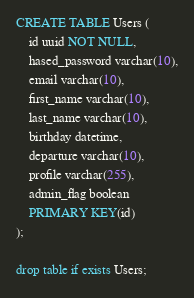Convert code to text. <code><loc_0><loc_0><loc_500><loc_500><_SQL_>CREATE TABLE Users (
	id uuid NOT NULL,
	hased_password varchar(10),
	email varchar(10),
	first_name varchar(10),
	last_name varchar(10),
	birthday datetime,
	departure varchar(10),
	profile varchar(255),
	admin_flag boolean
	PRIMARY KEY(id)
);

drop table if exists Users;
</code> 